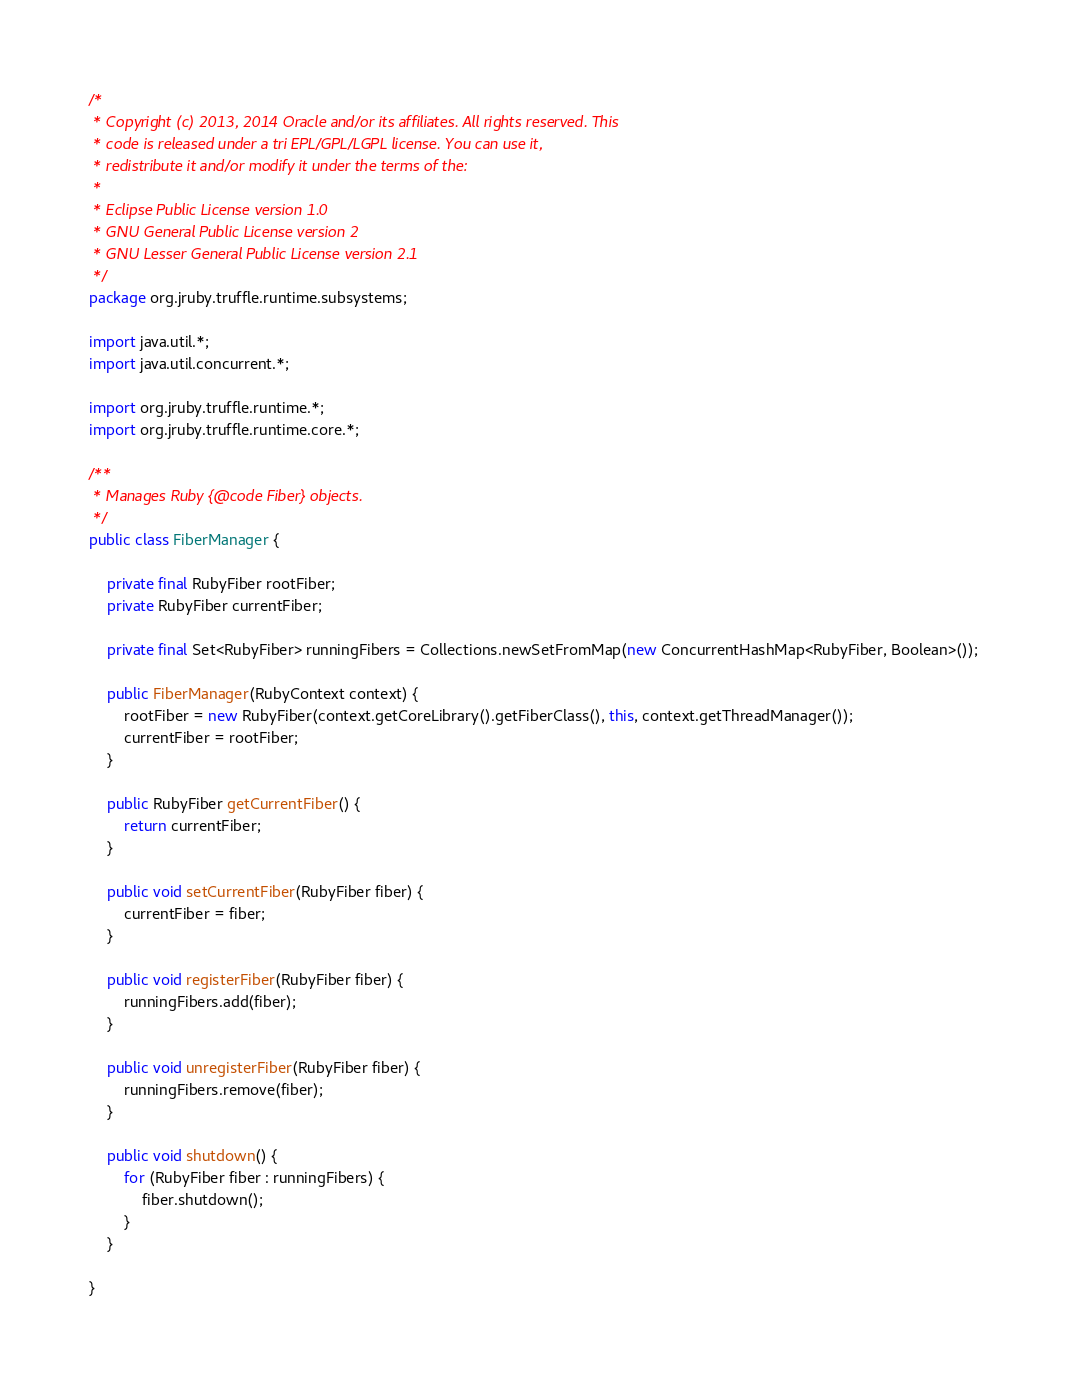Convert code to text. <code><loc_0><loc_0><loc_500><loc_500><_Java_>/*
 * Copyright (c) 2013, 2014 Oracle and/or its affiliates. All rights reserved. This
 * code is released under a tri EPL/GPL/LGPL license. You can use it,
 * redistribute it and/or modify it under the terms of the:
 *
 * Eclipse Public License version 1.0
 * GNU General Public License version 2
 * GNU Lesser General Public License version 2.1
 */
package org.jruby.truffle.runtime.subsystems;

import java.util.*;
import java.util.concurrent.*;

import org.jruby.truffle.runtime.*;
import org.jruby.truffle.runtime.core.*;

/**
 * Manages Ruby {@code Fiber} objects.
 */
public class FiberManager {

    private final RubyFiber rootFiber;
    private RubyFiber currentFiber;

    private final Set<RubyFiber> runningFibers = Collections.newSetFromMap(new ConcurrentHashMap<RubyFiber, Boolean>());

    public FiberManager(RubyContext context) {
        rootFiber = new RubyFiber(context.getCoreLibrary().getFiberClass(), this, context.getThreadManager());
        currentFiber = rootFiber;
    }

    public RubyFiber getCurrentFiber() {
        return currentFiber;
    }

    public void setCurrentFiber(RubyFiber fiber) {
        currentFiber = fiber;
    }

    public void registerFiber(RubyFiber fiber) {
        runningFibers.add(fiber);
    }

    public void unregisterFiber(RubyFiber fiber) {
        runningFibers.remove(fiber);
    }

    public void shutdown() {
        for (RubyFiber fiber : runningFibers) {
            fiber.shutdown();
        }
    }

}
</code> 